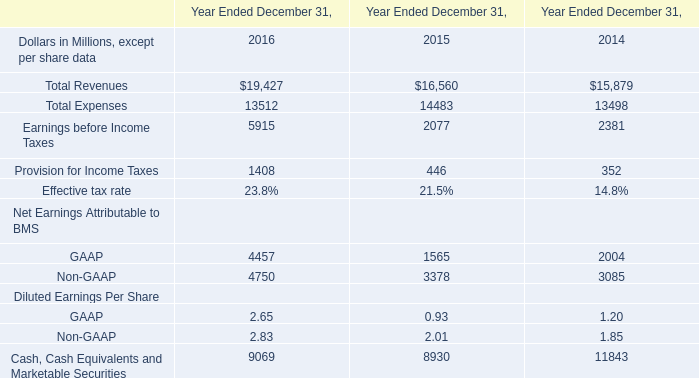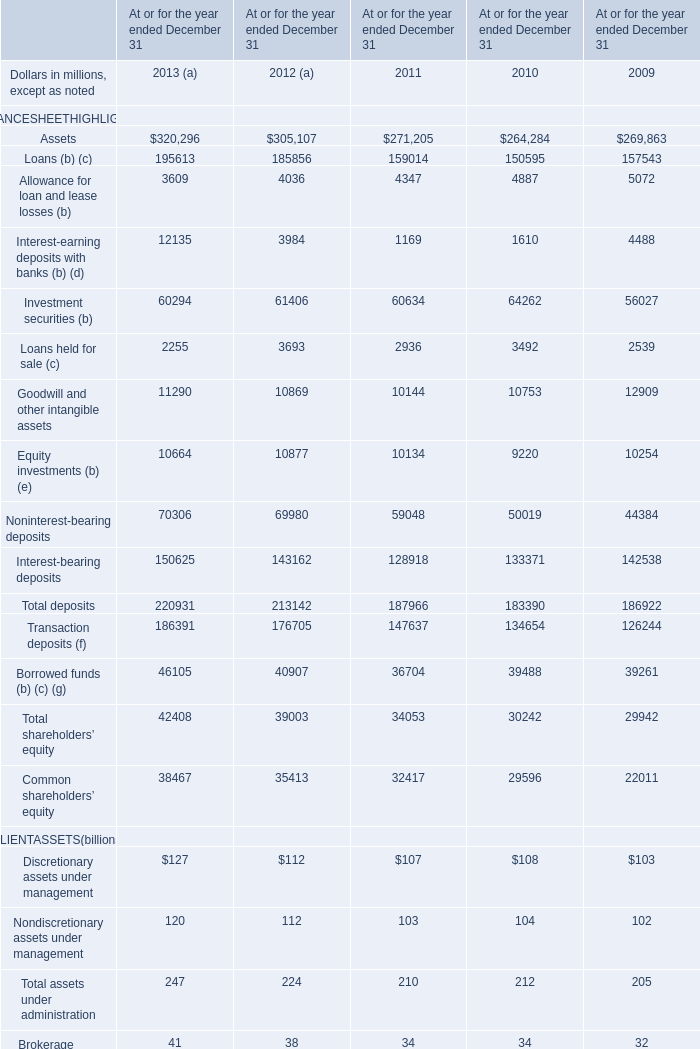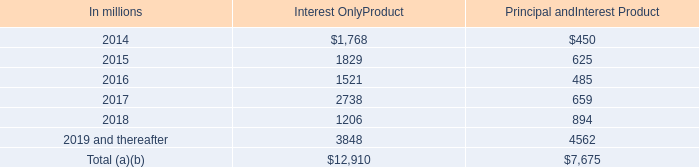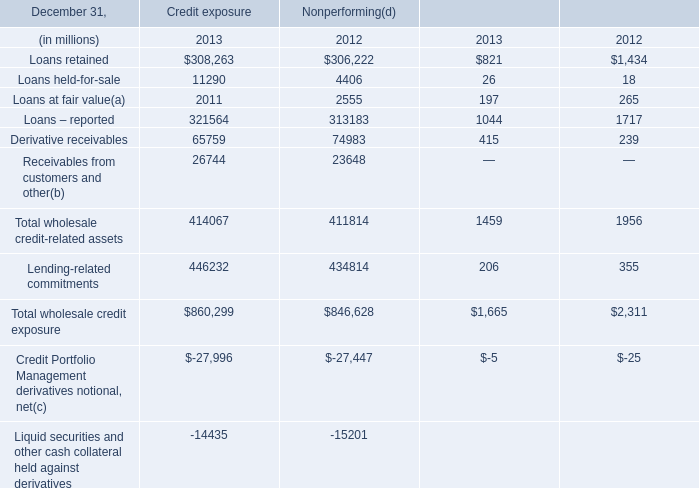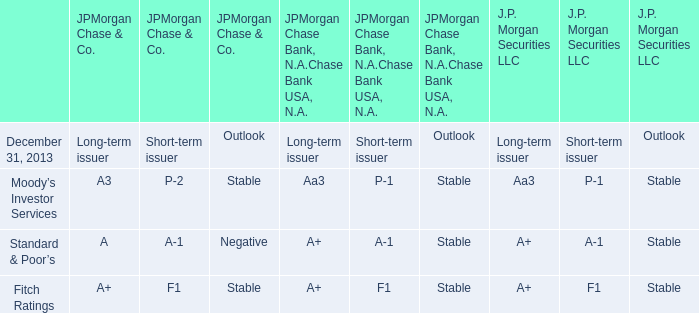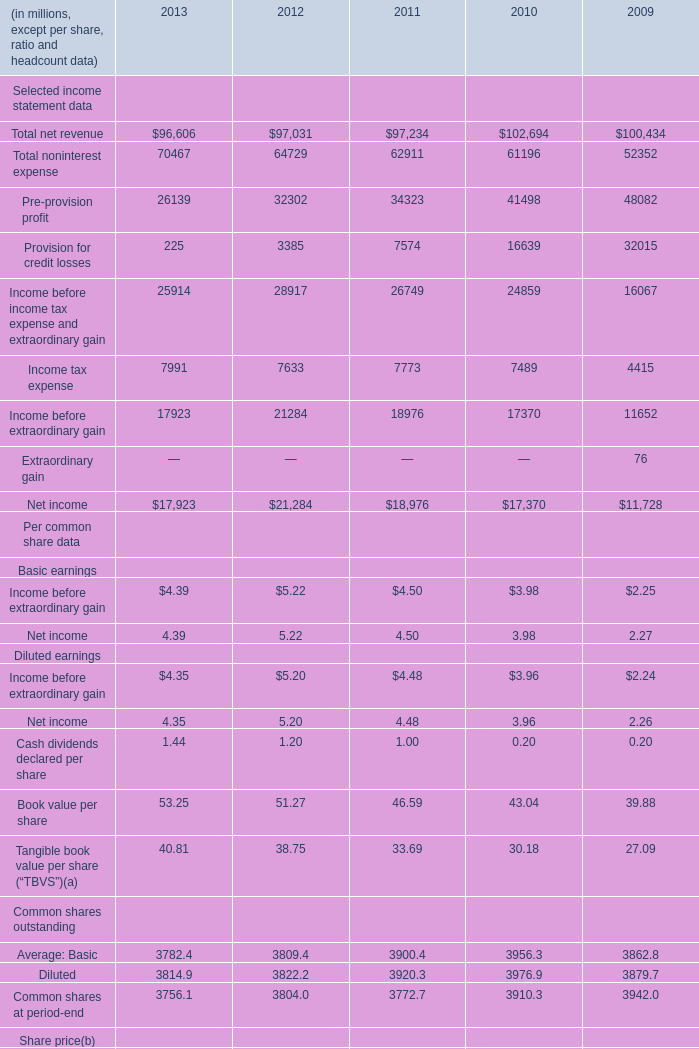What's the average of Receivables from customers and other of Credit exposure 2013, and Income before income tax expense and extraordinary gain of 2012 ? 
Computations: ((26744.0 + 28917.0) / 2)
Answer: 27830.5. 